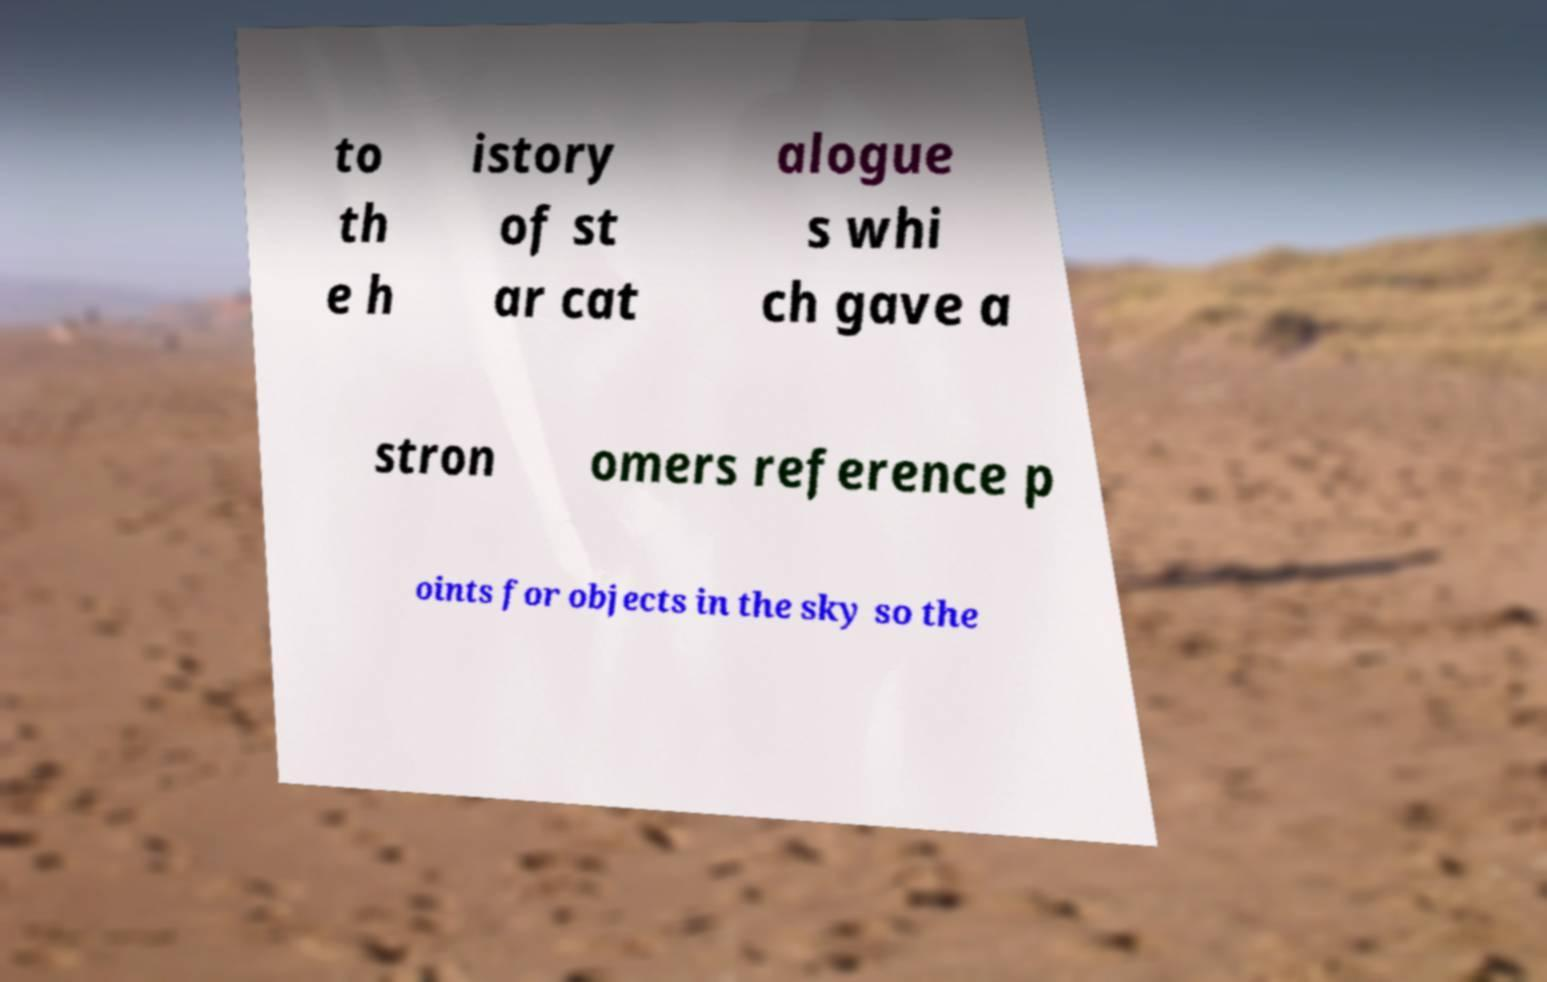What messages or text are displayed in this image? I need them in a readable, typed format. to th e h istory of st ar cat alogue s whi ch gave a stron omers reference p oints for objects in the sky so the 